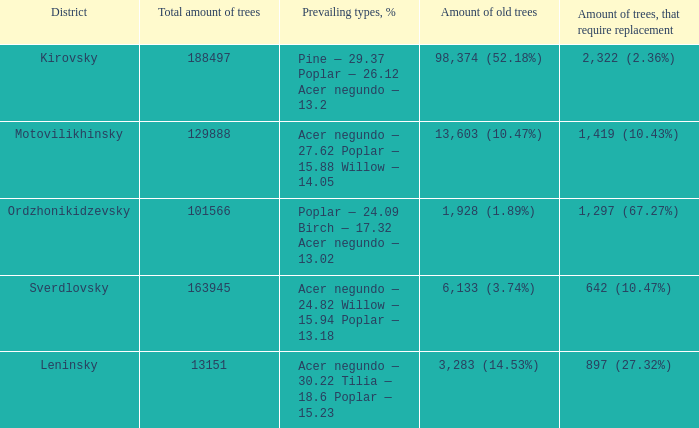What is the district when prevailing types, % is acer negundo — 30.22 tilia — 18.6 poplar — 15.23? Leninsky. 